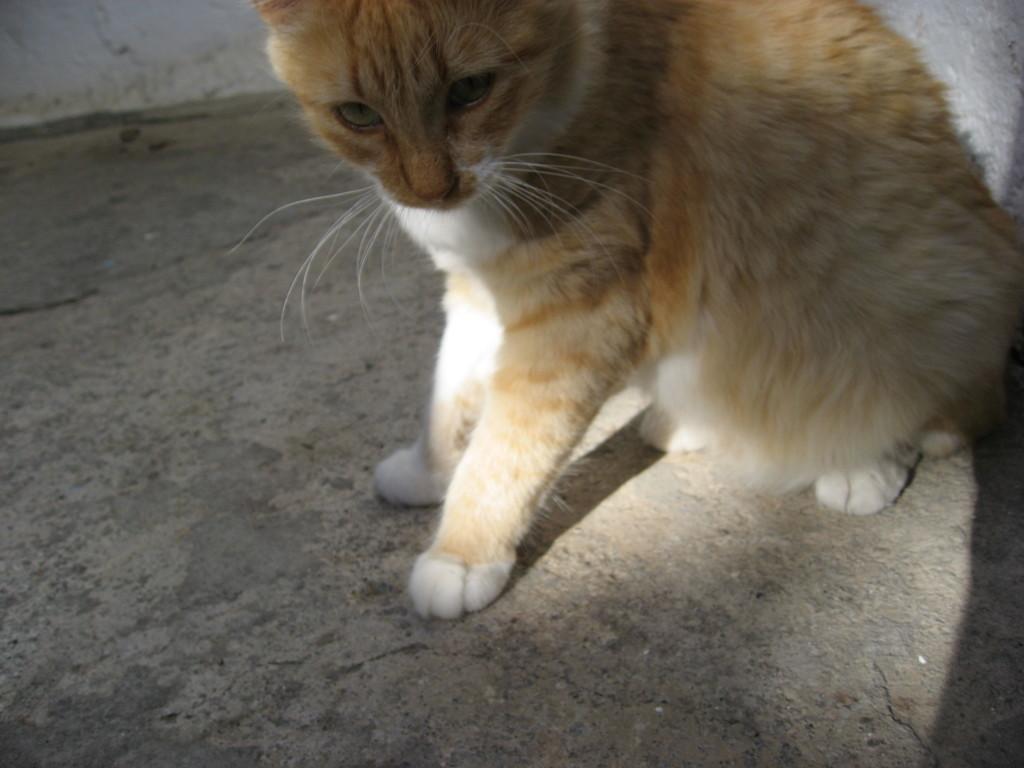How would you summarize this image in a sentence or two? In this image we can the cat. And we can see the cement floor. 